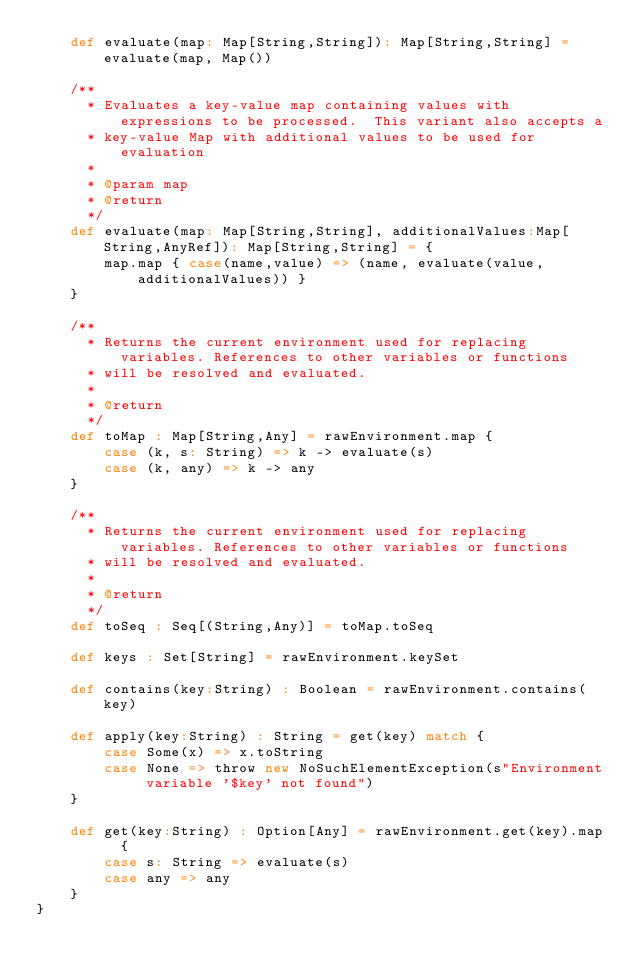Convert code to text. <code><loc_0><loc_0><loc_500><loc_500><_Scala_>    def evaluate(map: Map[String,String]): Map[String,String] = evaluate(map, Map())

    /**
      * Evaluates a key-value map containing values with expressions to be processed.  This variant also accepts a
      * key-value Map with additional values to be used for evaluation
      *
      * @param map
      * @return
      */
    def evaluate(map: Map[String,String], additionalValues:Map[String,AnyRef]): Map[String,String] = {
        map.map { case(name,value) => (name, evaluate(value, additionalValues)) }
    }

    /**
      * Returns the current environment used for replacing variables. References to other variables or functions
      * will be resolved and evaluated.
      *
      * @return
      */
    def toMap : Map[String,Any] = rawEnvironment.map {
        case (k, s: String) => k -> evaluate(s)
        case (k, any) => k -> any
    }

    /**
      * Returns the current environment used for replacing variables. References to other variables or functions
      * will be resolved and evaluated.
      *
      * @return
      */
    def toSeq : Seq[(String,Any)] = toMap.toSeq

    def keys : Set[String] = rawEnvironment.keySet

    def contains(key:String) : Boolean = rawEnvironment.contains(key)

    def apply(key:String) : String = get(key) match {
        case Some(x) => x.toString
        case None => throw new NoSuchElementException(s"Environment variable '$key' not found")
    }

    def get(key:String) : Option[Any] = rawEnvironment.get(key).map  {
        case s: String => evaluate(s)
        case any => any
    }
}
</code> 